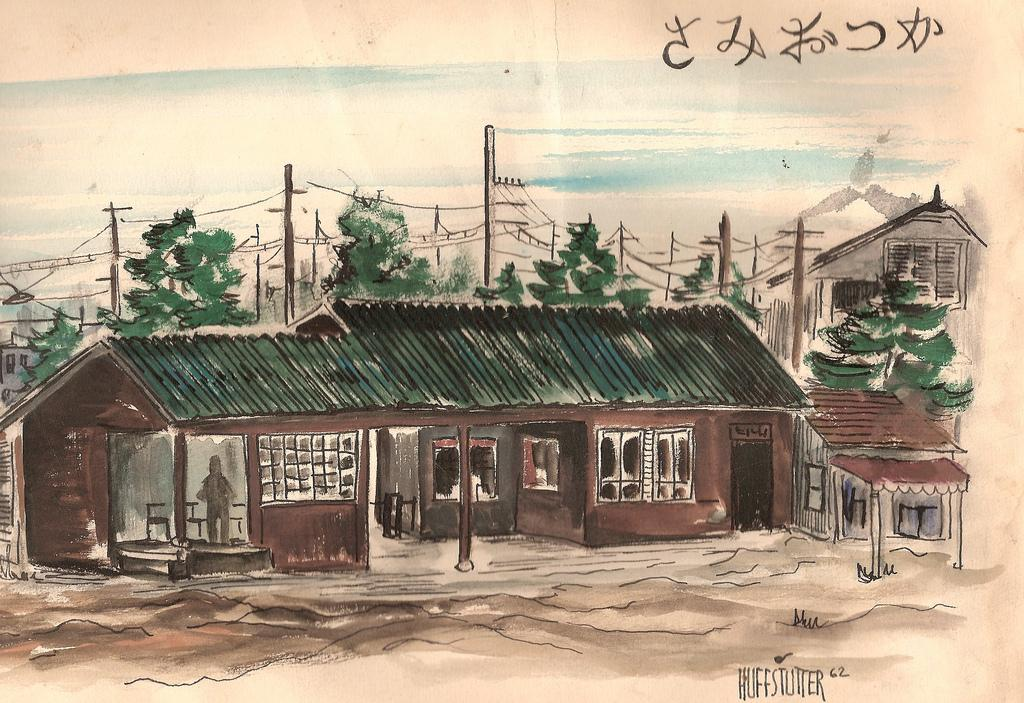What type of structures can be seen in the image? There are houses in the image. What other natural elements are present in the image? There are trees in the image. What architectural features can be observed on the houses? There are windows in the image. What utility infrastructure is visible in the image? There are current poles and wires in the image. What is the color of the sky in the image? The sky is white and blue in color. How many boys are playing with a net in the image? There are no boys or nets present in the image. What type of babies can be seen in the image? There are no babies present in the image. 